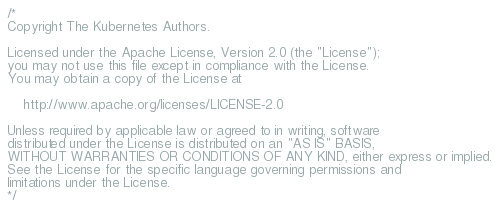Convert code to text. <code><loc_0><loc_0><loc_500><loc_500><_Go_>/*
Copyright The Kubernetes Authors.

Licensed under the Apache License, Version 2.0 (the "License");
you may not use this file except in compliance with the License.
You may obtain a copy of the License at

    http://www.apache.org/licenses/LICENSE-2.0

Unless required by applicable law or agreed to in writing, software
distributed under the License is distributed on an "AS IS" BASIS,
WITHOUT WARRANTIES OR CONDITIONS OF ANY KIND, either express or implied.
See the License for the specific language governing permissions and
limitations under the License.
*/
</code> 